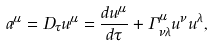Convert formula to latex. <formula><loc_0><loc_0><loc_500><loc_500>a ^ { \mu } = D _ { \tau } u ^ { \mu } = \frac { d u ^ { \mu } } { d \tau } + \Gamma ^ { \mu } _ { \nu \lambda } u ^ { \nu } u ^ { \lambda } ,</formula> 